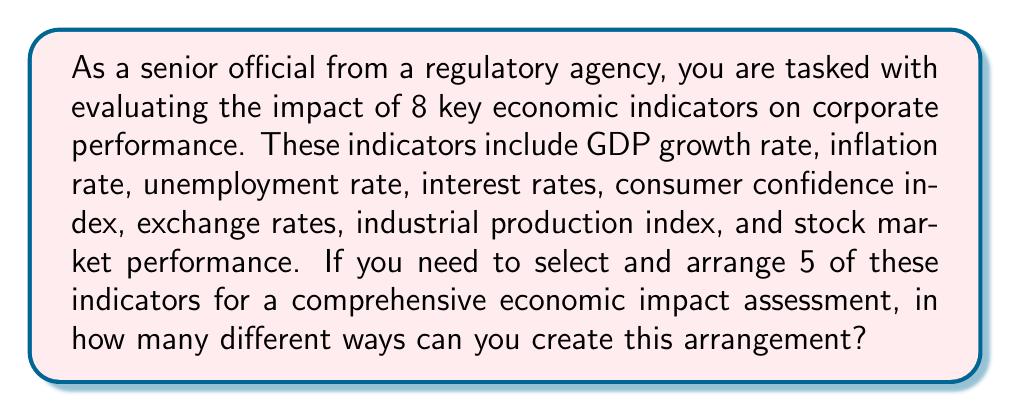Help me with this question. To solve this problem, we need to use the concept of permutations. We are selecting 5 indicators out of 8 and arranging them in a specific order, which means the order matters.

The formula for permutations when selecting $r$ items from $n$ items is:

$$P(n,r) = \frac{n!}{(n-r)!}$$

Where:
$n$ = total number of items to choose from
$r$ = number of items being chosen

In this case:
$n = 8$ (total number of economic indicators)
$r = 5$ (number of indicators we're selecting and arranging)

Let's substitute these values into the formula:

$$P(8,5) = \frac{8!}{(8-5)!} = \frac{8!}{3!}$$

Now, let's calculate this step-by-step:

1) $8! = 8 \times 7 \times 6 \times 5 \times 4 \times 3 \times 2 \times 1 = 40,320$
2) $3! = 3 \times 2 \times 1 = 6$

3) $\frac{8!}{3!} = \frac{40,320}{6} = 6,720$

Therefore, there are 6,720 different ways to select and arrange 5 economic indicators out of the 8 given indicators.
Answer: 6,720 permutations 